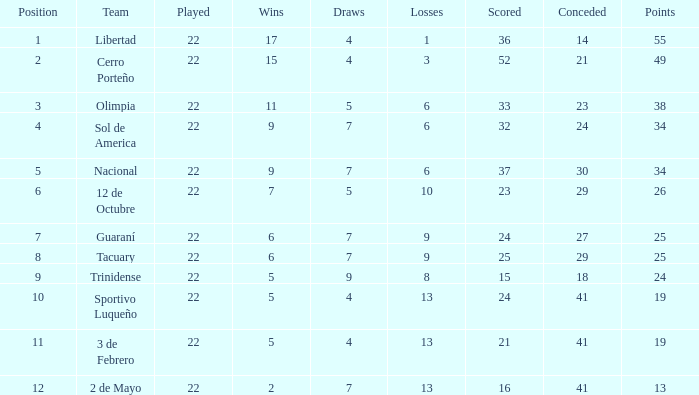What is the quantity of stalemates for the group with in excess of 8 losses and 13 points? 7.0. 